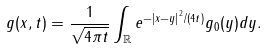<formula> <loc_0><loc_0><loc_500><loc_500>g ( x , t ) = \frac { 1 } { \sqrt { 4 \pi t } } \int _ { \mathbb { R } } e ^ { - \left | x - y \right | ^ { 2 } / ( 4 t ) } g _ { 0 } ( y ) d y .</formula> 